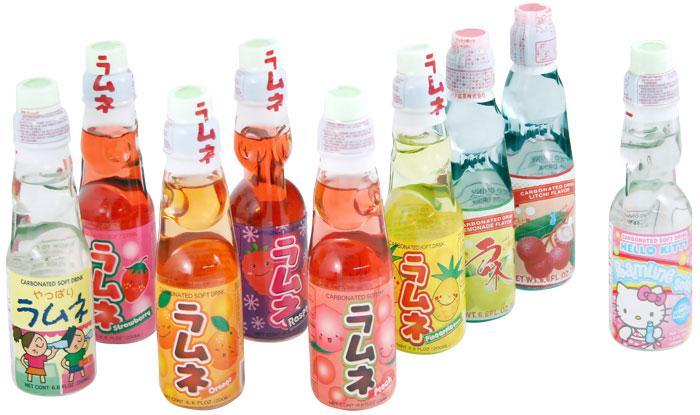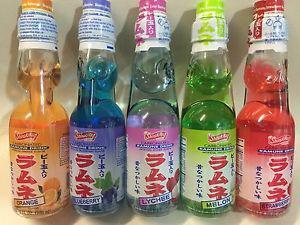The first image is the image on the left, the second image is the image on the right. Examine the images to the left and right. Is the description "There are exactly six bottles in the right image." accurate? Answer yes or no. No. The first image is the image on the left, the second image is the image on the right. Assess this claim about the two images: "The left image features a row of at least six empty soda bottles without lids, and the right image shows exactly six filled bottles of soda with caps on.". Correct or not? Answer yes or no. No. 